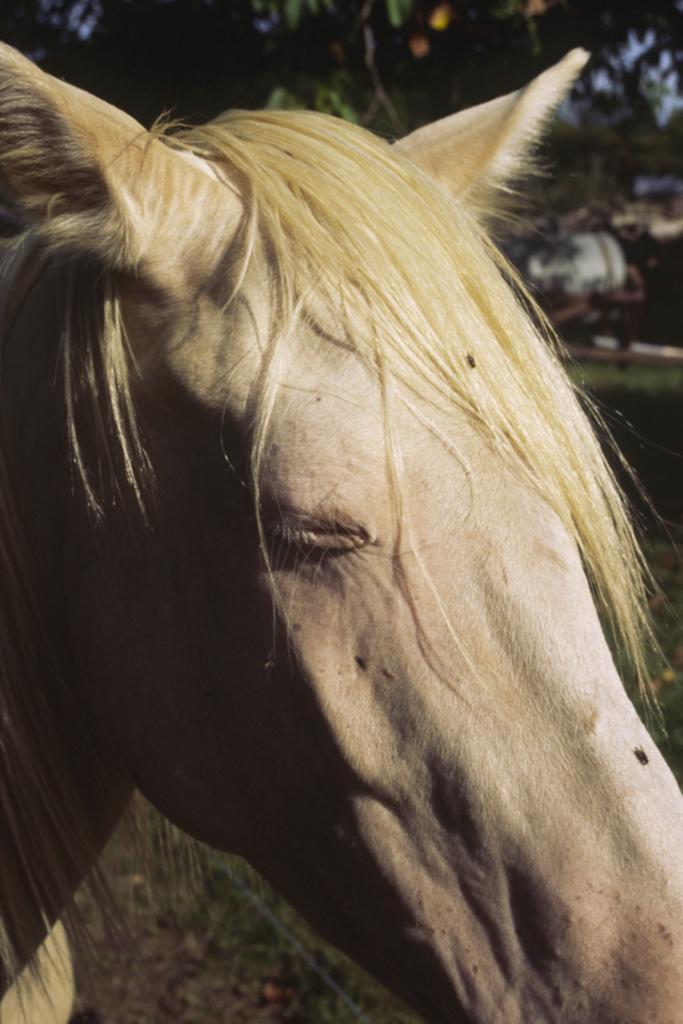How would you summarize this image in a sentence or two? In this image I can see an animal in cream color. In the background I can see few trees in green color and the sky is in blue color. 